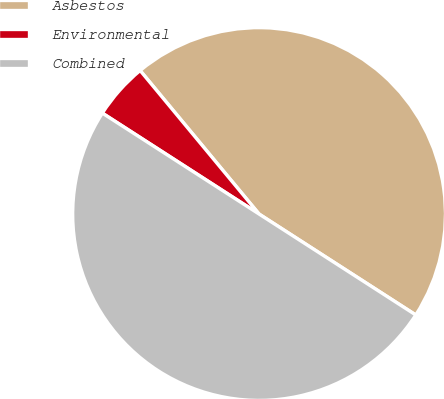Convert chart to OTSL. <chart><loc_0><loc_0><loc_500><loc_500><pie_chart><fcel>Asbestos<fcel>Environmental<fcel>Combined<nl><fcel>45.12%<fcel>4.88%<fcel>50.0%<nl></chart> 